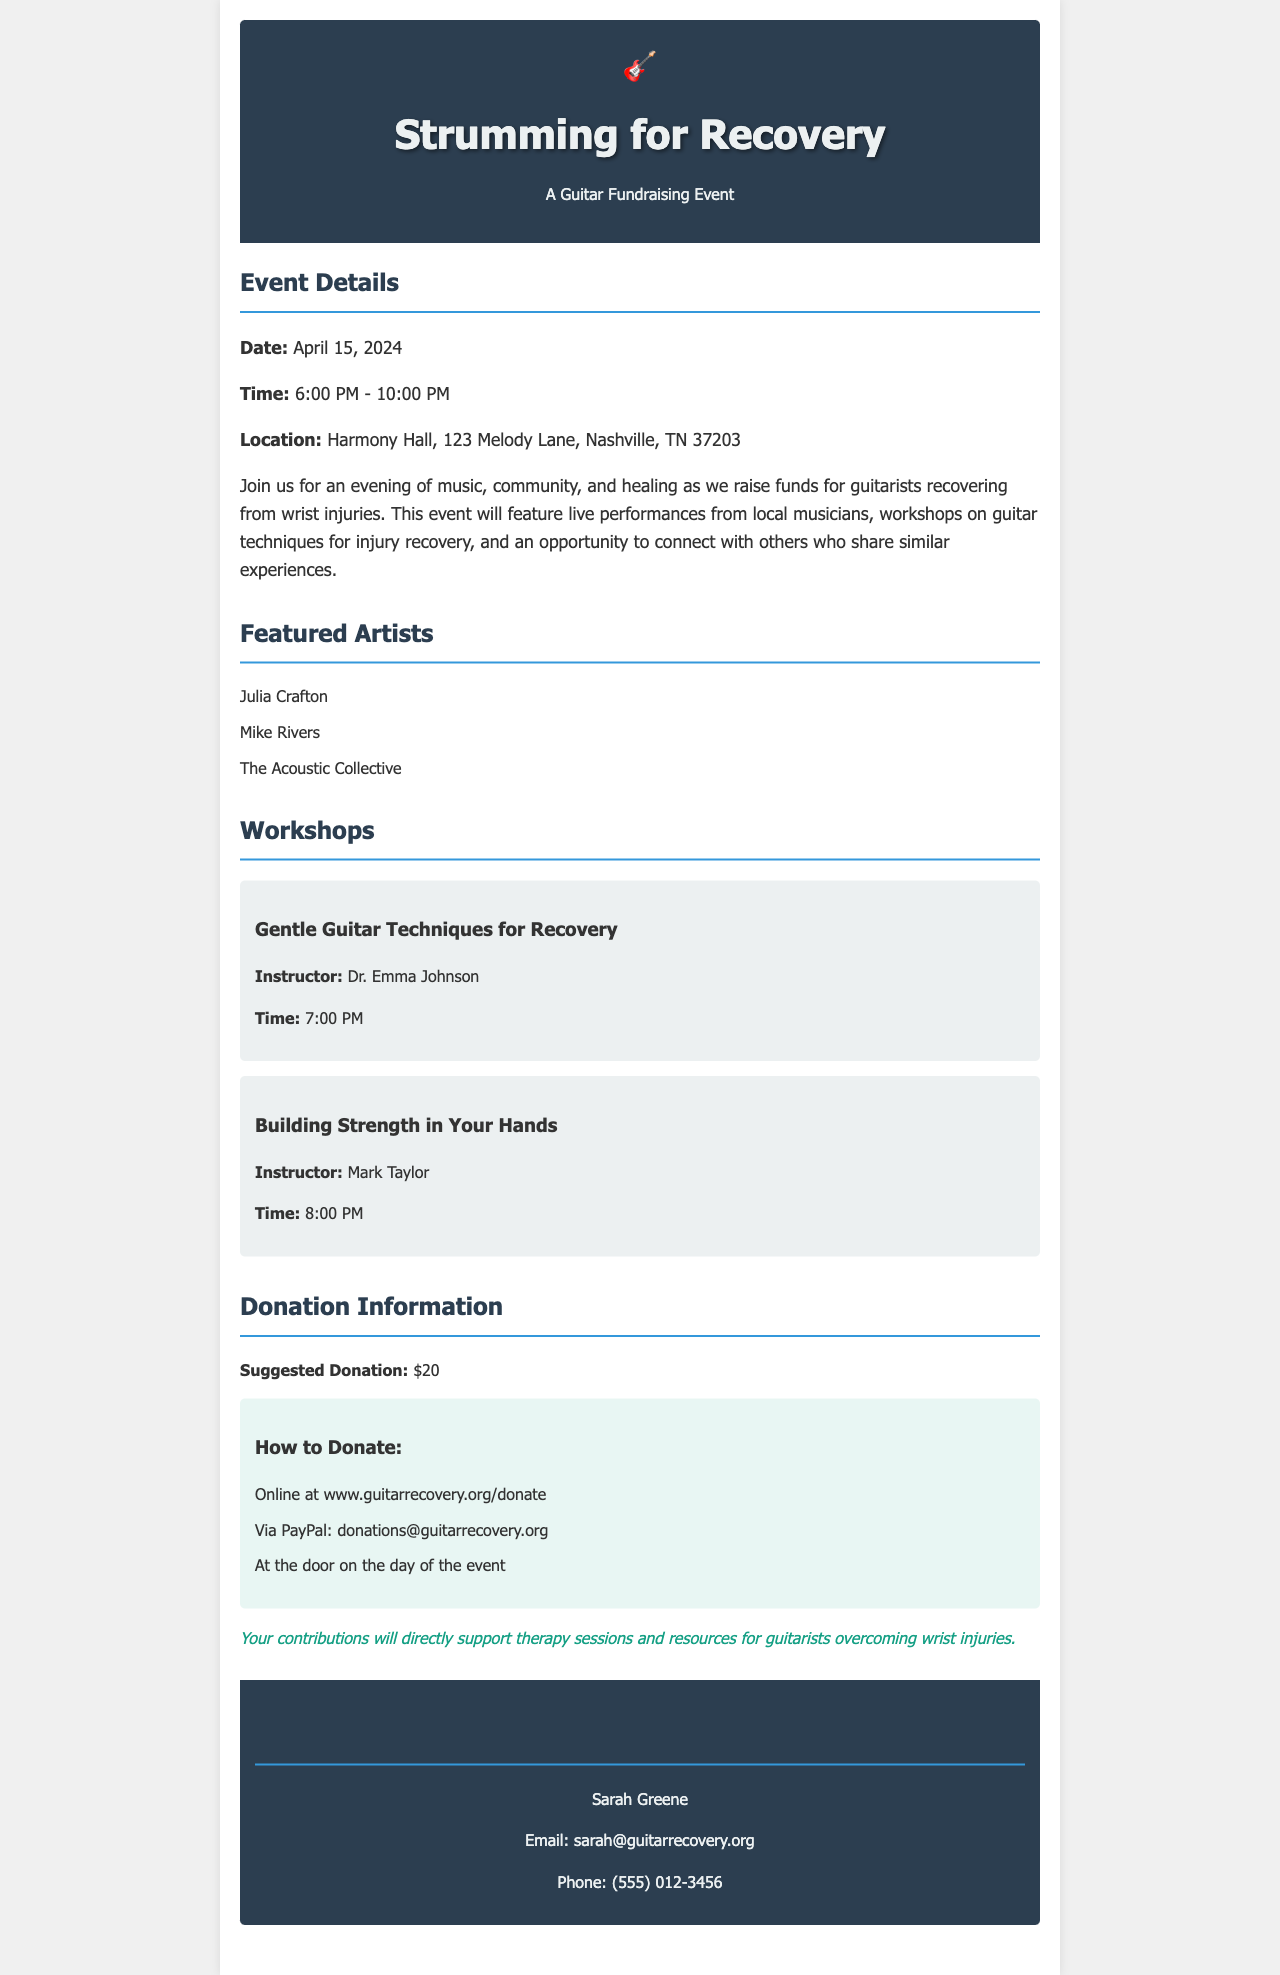What is the date of the event? The date mentioned in the event details section is crucial for attendees to plan accordingly.
Answer: April 15, 2024 What time does the event start? This is important for participants to know when to arrive at the venue.
Answer: 6:00 PM Where is the event being held? The location is provided to guide participants to the venue.
Answer: Harmony Hall, 123 Melody Lane, Nashville, TN 37203 Who is the instructor for the workshop on gentle guitar techniques? Knowing the instructor can inform participants about their expertise and background.
Answer: Dr. Emma Johnson What is the suggested donation amount? This information helps potential donors to understand the financial support needed.
Answer: $20 Which PayPal address can be used for donations? This address allows supporters to contribute financially online.
Answer: donations@guitarrecovery.org What is one of the featured artists at the event? Identifying featured artists can entice attendees interested in their music.
Answer: Julia Crafton What is the impact of donations stated in the document? Understanding the use of donations encourages contributors to give.
Answer: Therapy sessions and resources for guitarists overcoming wrist injuries 